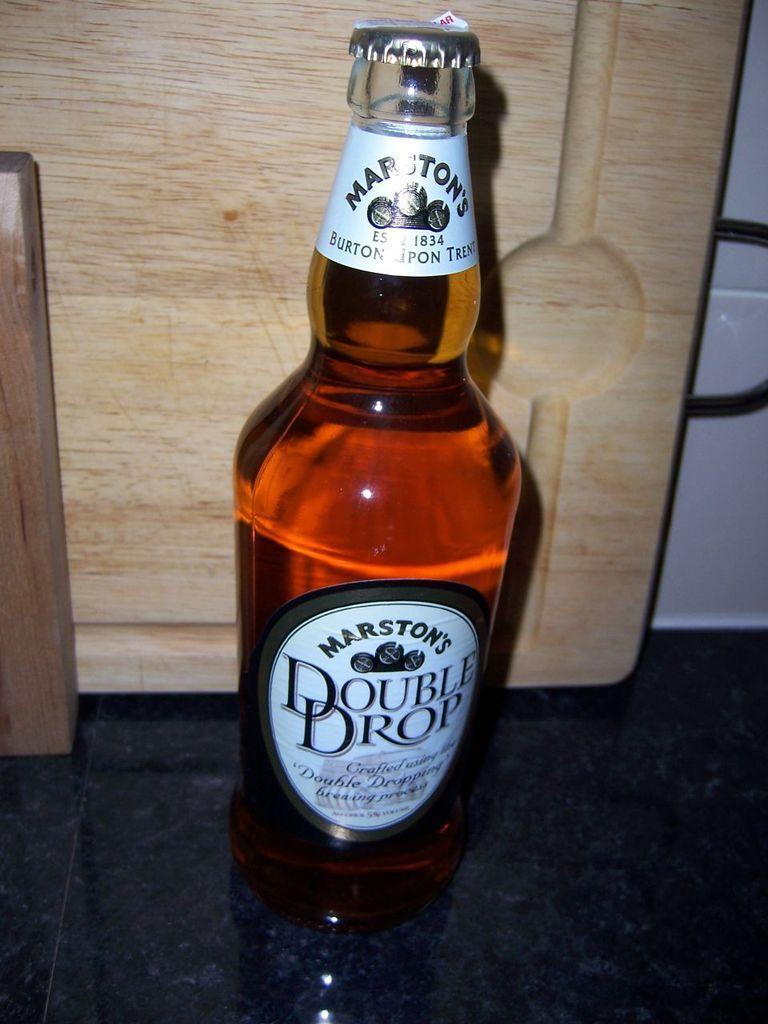Can you describe this image briefly? In this image, There is a floor which is in black color on that floor there is a wine bottle which is in brown color and in the background there is a wooden block which is in yellow color. 